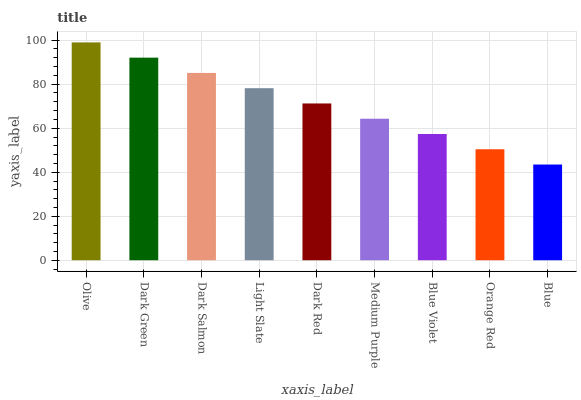Is Blue the minimum?
Answer yes or no. Yes. Is Olive the maximum?
Answer yes or no. Yes. Is Dark Green the minimum?
Answer yes or no. No. Is Dark Green the maximum?
Answer yes or no. No. Is Olive greater than Dark Green?
Answer yes or no. Yes. Is Dark Green less than Olive?
Answer yes or no. Yes. Is Dark Green greater than Olive?
Answer yes or no. No. Is Olive less than Dark Green?
Answer yes or no. No. Is Dark Red the high median?
Answer yes or no. Yes. Is Dark Red the low median?
Answer yes or no. Yes. Is Olive the high median?
Answer yes or no. No. Is Medium Purple the low median?
Answer yes or no. No. 